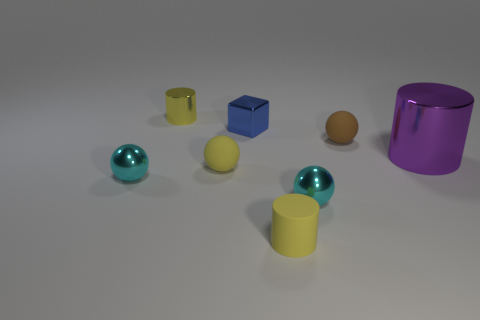Add 2 blue shiny things. How many objects exist? 10 Subtract all cylinders. How many objects are left? 5 Add 7 tiny brown shiny balls. How many tiny brown shiny balls exist? 7 Subtract 0 blue balls. How many objects are left? 8 Subtract all large metal objects. Subtract all big metal cylinders. How many objects are left? 6 Add 7 small blue blocks. How many small blue blocks are left? 8 